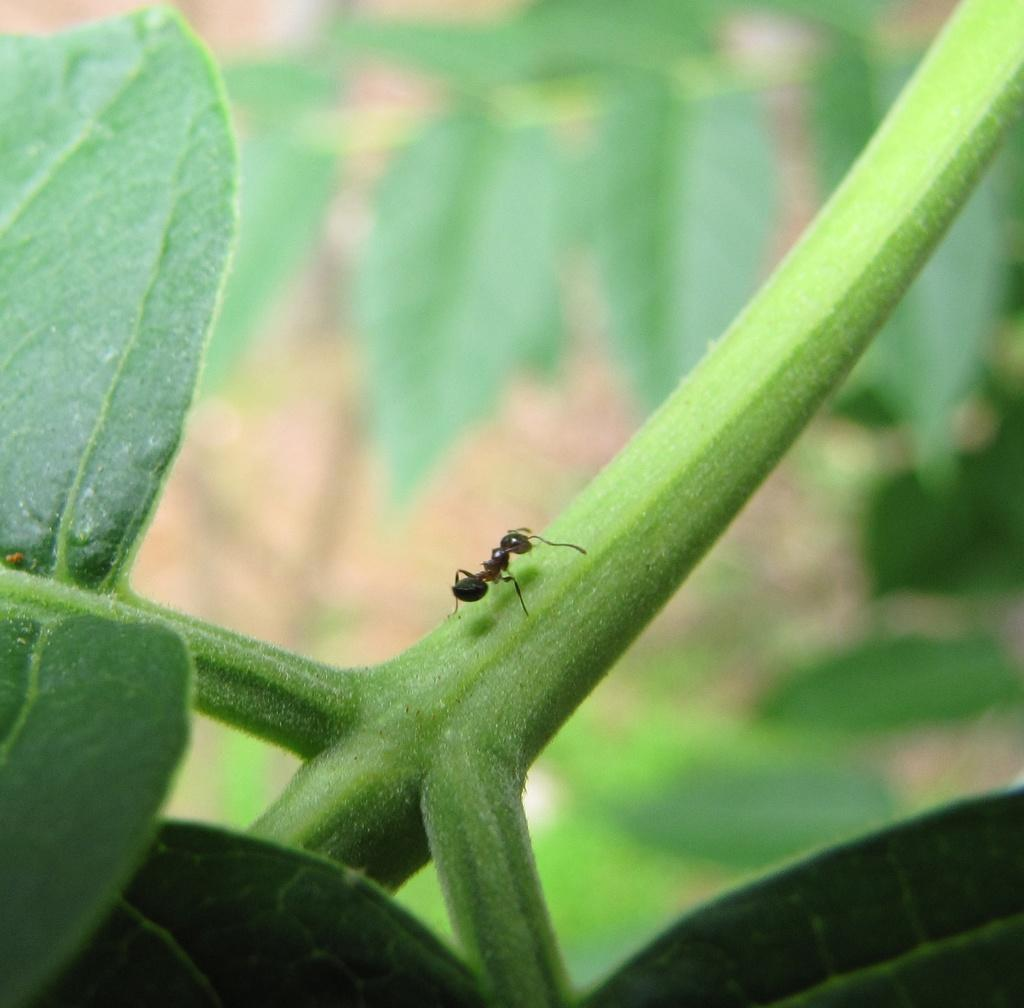What is the main subject of the image? The main subject of the image is an ant. Where is the ant located in the image? The ant is on a plant. Can you describe the position of the ant in the image? The ant is located in the center of the image. What type of wire is the ant using to climb the plant in the image? There is no wire present in the image; the ant is on a plant without any visible wire. 